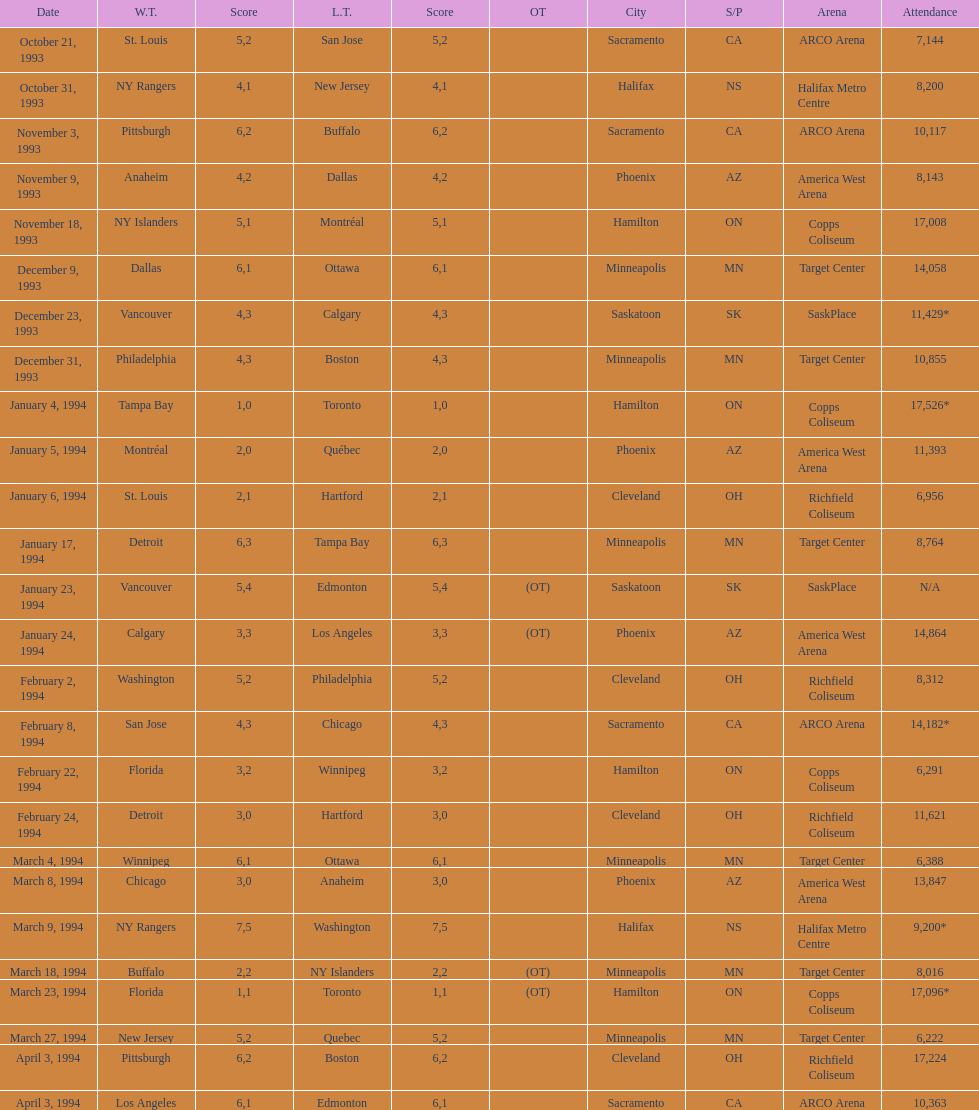Help me parse the entirety of this table. {'header': ['Date', 'W.T.', 'Score', 'L.T.', 'Score', 'OT', 'City', 'S/P', 'Arena', 'Attendance'], 'rows': [['October 21, 1993', 'St. Louis', '5', 'San Jose', '2', '', 'Sacramento', 'CA', 'ARCO Arena', '7,144'], ['October 31, 1993', 'NY Rangers', '4', 'New Jersey', '1', '', 'Halifax', 'NS', 'Halifax Metro Centre', '8,200'], ['November 3, 1993', 'Pittsburgh', '6', 'Buffalo', '2', '', 'Sacramento', 'CA', 'ARCO Arena', '10,117'], ['November 9, 1993', 'Anaheim', '4', 'Dallas', '2', '', 'Phoenix', 'AZ', 'America West Arena', '8,143'], ['November 18, 1993', 'NY Islanders', '5', 'Montréal', '1', '', 'Hamilton', 'ON', 'Copps Coliseum', '17,008'], ['December 9, 1993', 'Dallas', '6', 'Ottawa', '1', '', 'Minneapolis', 'MN', 'Target Center', '14,058'], ['December 23, 1993', 'Vancouver', '4', 'Calgary', '3', '', 'Saskatoon', 'SK', 'SaskPlace', '11,429*'], ['December 31, 1993', 'Philadelphia', '4', 'Boston', '3', '', 'Minneapolis', 'MN', 'Target Center', '10,855'], ['January 4, 1994', 'Tampa Bay', '1', 'Toronto', '0', '', 'Hamilton', 'ON', 'Copps Coliseum', '17,526*'], ['January 5, 1994', 'Montréal', '2', 'Québec', '0', '', 'Phoenix', 'AZ', 'America West Arena', '11,393'], ['January 6, 1994', 'St. Louis', '2', 'Hartford', '1', '', 'Cleveland', 'OH', 'Richfield Coliseum', '6,956'], ['January 17, 1994', 'Detroit', '6', 'Tampa Bay', '3', '', 'Minneapolis', 'MN', 'Target Center', '8,764'], ['January 23, 1994', 'Vancouver', '5', 'Edmonton', '4', '(OT)', 'Saskatoon', 'SK', 'SaskPlace', 'N/A'], ['January 24, 1994', 'Calgary', '3', 'Los Angeles', '3', '(OT)', 'Phoenix', 'AZ', 'America West Arena', '14,864'], ['February 2, 1994', 'Washington', '5', 'Philadelphia', '2', '', 'Cleveland', 'OH', 'Richfield Coliseum', '8,312'], ['February 8, 1994', 'San Jose', '4', 'Chicago', '3', '', 'Sacramento', 'CA', 'ARCO Arena', '14,182*'], ['February 22, 1994', 'Florida', '3', 'Winnipeg', '2', '', 'Hamilton', 'ON', 'Copps Coliseum', '6,291'], ['February 24, 1994', 'Detroit', '3', 'Hartford', '0', '', 'Cleveland', 'OH', 'Richfield Coliseum', '11,621'], ['March 4, 1994', 'Winnipeg', '6', 'Ottawa', '1', '', 'Minneapolis', 'MN', 'Target Center', '6,388'], ['March 8, 1994', 'Chicago', '3', 'Anaheim', '0', '', 'Phoenix', 'AZ', 'America West Arena', '13,847'], ['March 9, 1994', 'NY Rangers', '7', 'Washington', '5', '', 'Halifax', 'NS', 'Halifax Metro Centre', '9,200*'], ['March 18, 1994', 'Buffalo', '2', 'NY Islanders', '2', '(OT)', 'Minneapolis', 'MN', 'Target Center', '8,016'], ['March 23, 1994', 'Florida', '1', 'Toronto', '1', '(OT)', 'Hamilton', 'ON', 'Copps Coliseum', '17,096*'], ['March 27, 1994', 'New Jersey', '5', 'Quebec', '2', '', 'Minneapolis', 'MN', 'Target Center', '6,222'], ['April 3, 1994', 'Pittsburgh', '6', 'Boston', '2', '', 'Cleveland', 'OH', 'Richfield Coliseum', '17,224'], ['April 3, 1994', 'Los Angeles', '6', 'Edmonton', '1', '', 'Sacramento', 'CA', 'ARCO Arena', '10,363']]} How many contests have taken place in minneapolis? 6. 